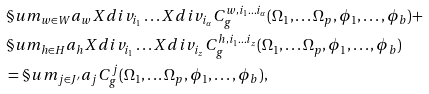Convert formula to latex. <formula><loc_0><loc_0><loc_500><loc_500>& \S u m _ { w \in W } a _ { w } X d i v _ { i _ { 1 } } \dots X d i v _ { i _ { \alpha } } C ^ { w , i _ { 1 } \dots i _ { \alpha } } _ { g } ( \Omega _ { 1 } , \dots \Omega _ { p } , \phi _ { 1 } , \dots , \phi _ { b } ) + \\ & \S u m _ { h \in H } a _ { h } X d i v _ { i _ { 1 } } \dots X d i v _ { i _ { z } } C ^ { h , i _ { 1 } \dots i _ { z } } _ { g } ( \Omega _ { 1 } , \dots \Omega _ { p } , \phi _ { 1 } , \dots , \phi _ { b } ) \\ & = \S u m _ { j \in J ^ { \prime } } a _ { j } C ^ { j } _ { g } ( \Omega _ { 1 } , \dots \Omega _ { p } , \phi _ { 1 } , \dots , \phi _ { b } ) ,</formula> 